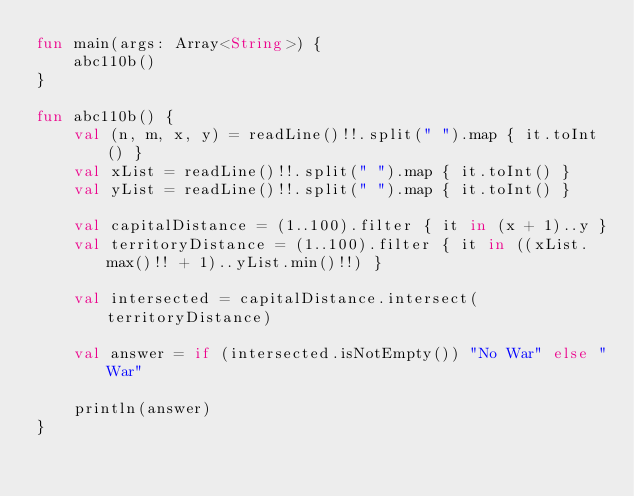<code> <loc_0><loc_0><loc_500><loc_500><_Kotlin_>fun main(args: Array<String>) {
    abc110b()
}

fun abc110b() {
    val (n, m, x, y) = readLine()!!.split(" ").map { it.toInt() }
    val xList = readLine()!!.split(" ").map { it.toInt() }
    val yList = readLine()!!.split(" ").map { it.toInt() }

    val capitalDistance = (1..100).filter { it in (x + 1)..y }
    val territoryDistance = (1..100).filter { it in ((xList.max()!! + 1)..yList.min()!!) }

    val intersected = capitalDistance.intersect(territoryDistance)

    val answer = if (intersected.isNotEmpty()) "No War" else "War"

    println(answer)
}
</code> 